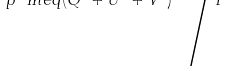Convert formula to latex. <formula><loc_0><loc_0><loc_500><loc_500>p \ m e q ( Q ^ { 2 } + U ^ { 2 } + V ^ { 2 } ) ^ { 1 / 2 } { \Big / } I</formula> 